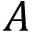<formula> <loc_0><loc_0><loc_500><loc_500>A</formula> 